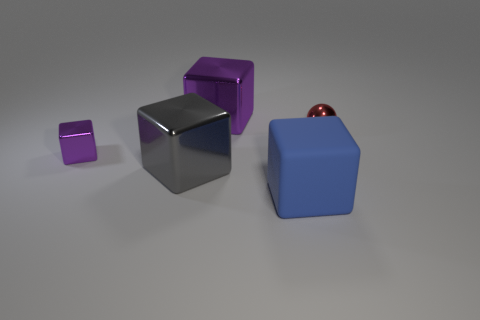Subtract all brown blocks. Subtract all blue cylinders. How many blocks are left? 4 Add 4 spheres. How many objects exist? 9 Subtract all blocks. How many objects are left? 1 Subtract all blue things. Subtract all metallic cubes. How many objects are left? 1 Add 4 balls. How many balls are left? 5 Add 3 big rubber objects. How many big rubber objects exist? 4 Subtract 0 yellow cylinders. How many objects are left? 5 